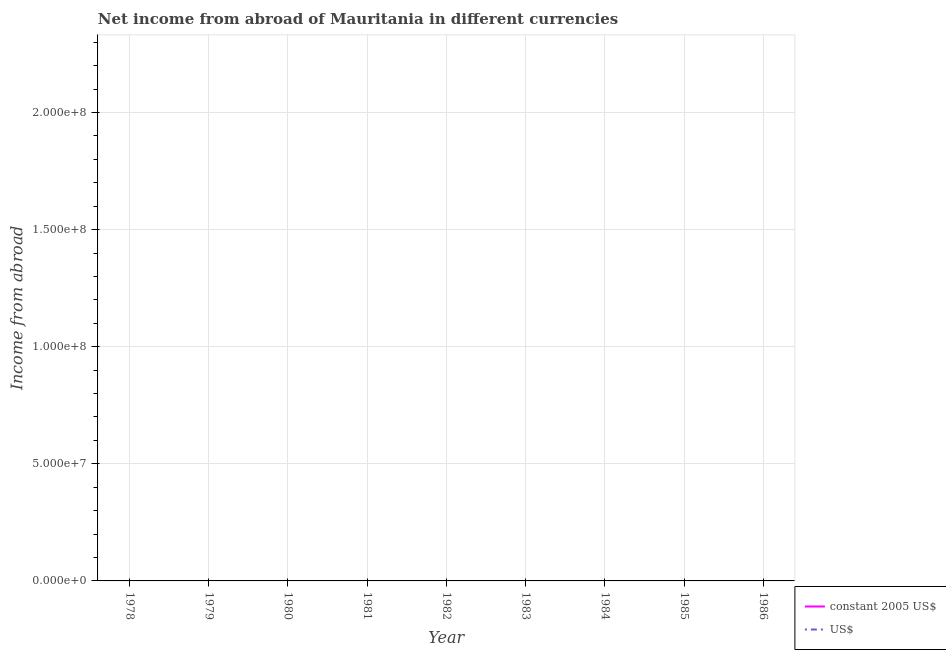Does the line corresponding to income from abroad in us$ intersect with the line corresponding to income from abroad in constant 2005 us$?
Offer a terse response. No. Across all years, what is the minimum income from abroad in us$?
Make the answer very short. 0. What is the total income from abroad in constant 2005 us$ in the graph?
Make the answer very short. 0. What is the average income from abroad in us$ per year?
Your response must be concise. 0. In how many years, is the income from abroad in us$ greater than the average income from abroad in us$ taken over all years?
Ensure brevity in your answer.  0. Does the income from abroad in us$ monotonically increase over the years?
Provide a succinct answer. No. Is the income from abroad in constant 2005 us$ strictly greater than the income from abroad in us$ over the years?
Ensure brevity in your answer.  No. Is the income from abroad in us$ strictly less than the income from abroad in constant 2005 us$ over the years?
Ensure brevity in your answer.  No. How many lines are there?
Your response must be concise. 0. What is the difference between two consecutive major ticks on the Y-axis?
Make the answer very short. 5.00e+07. Does the graph contain any zero values?
Your response must be concise. Yes. Where does the legend appear in the graph?
Offer a terse response. Bottom right. How many legend labels are there?
Keep it short and to the point. 2. What is the title of the graph?
Give a very brief answer. Net income from abroad of Mauritania in different currencies. What is the label or title of the X-axis?
Offer a very short reply. Year. What is the label or title of the Y-axis?
Provide a short and direct response. Income from abroad. What is the Income from abroad in constant 2005 US$ in 1978?
Offer a very short reply. 0. What is the Income from abroad of US$ in 1979?
Provide a succinct answer. 0. What is the Income from abroad of constant 2005 US$ in 1980?
Ensure brevity in your answer.  0. What is the Income from abroad in US$ in 1980?
Your answer should be very brief. 0. What is the Income from abroad of constant 2005 US$ in 1981?
Your response must be concise. 0. What is the Income from abroad in US$ in 1981?
Your answer should be compact. 0. What is the Income from abroad of constant 2005 US$ in 1984?
Give a very brief answer. 0. What is the Income from abroad in US$ in 1985?
Ensure brevity in your answer.  0. What is the Income from abroad in constant 2005 US$ in 1986?
Your answer should be very brief. 0. What is the Income from abroad of US$ in 1986?
Ensure brevity in your answer.  0. What is the total Income from abroad in constant 2005 US$ in the graph?
Your response must be concise. 0. What is the total Income from abroad in US$ in the graph?
Make the answer very short. 0. What is the average Income from abroad in constant 2005 US$ per year?
Your answer should be compact. 0. What is the average Income from abroad in US$ per year?
Your answer should be compact. 0. 